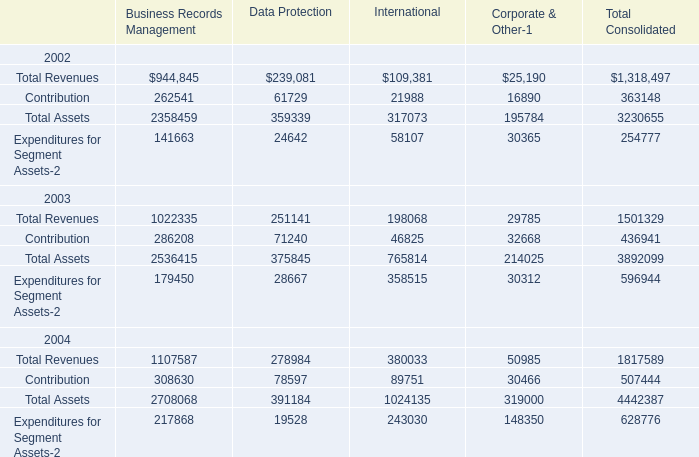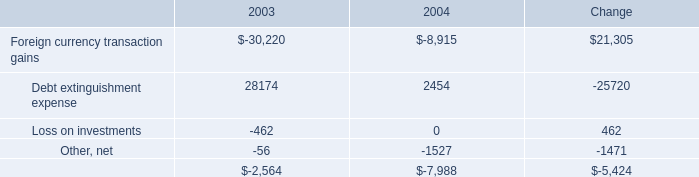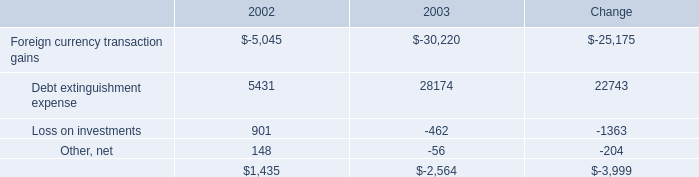If Contribution for Data Protection develops with the same growth rate in 2003, what will it reach in 2004? 
Computations: ((1 + ((71240 - 61729) / 61729)) * 71240)
Answer: 82216.4234. 